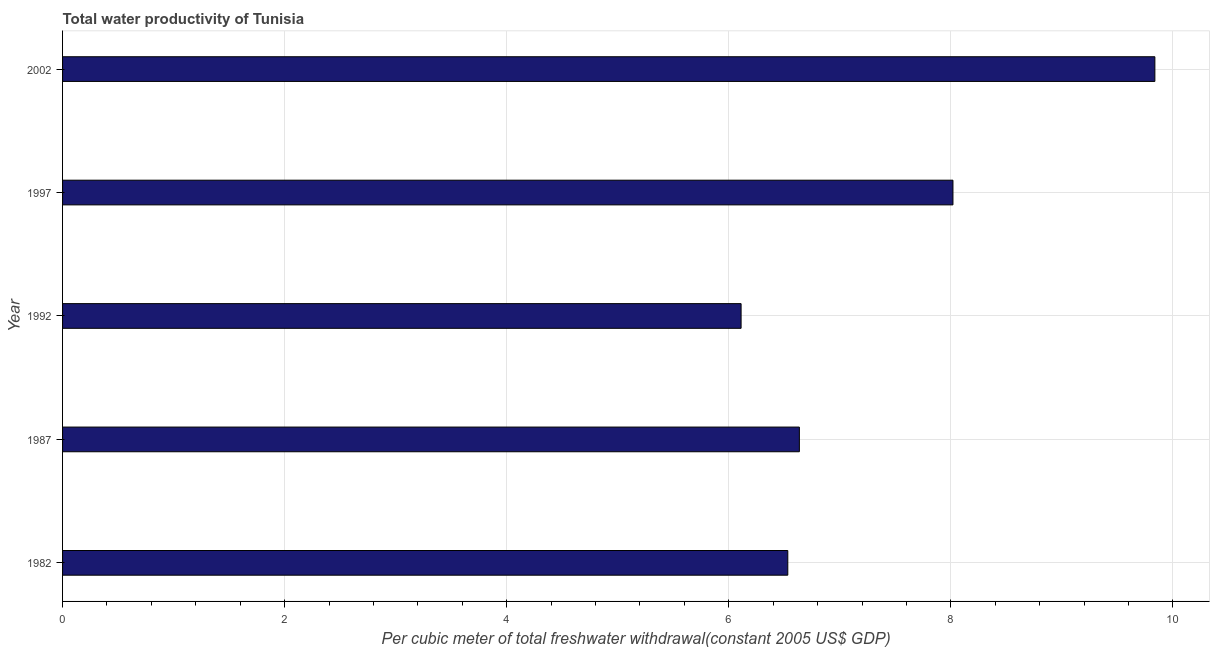Does the graph contain any zero values?
Provide a short and direct response. No. Does the graph contain grids?
Provide a short and direct response. Yes. What is the title of the graph?
Provide a short and direct response. Total water productivity of Tunisia. What is the label or title of the X-axis?
Offer a very short reply. Per cubic meter of total freshwater withdrawal(constant 2005 US$ GDP). What is the label or title of the Y-axis?
Ensure brevity in your answer.  Year. What is the total water productivity in 1997?
Your answer should be very brief. 8.02. Across all years, what is the maximum total water productivity?
Provide a short and direct response. 9.84. Across all years, what is the minimum total water productivity?
Give a very brief answer. 6.11. In which year was the total water productivity maximum?
Offer a very short reply. 2002. In which year was the total water productivity minimum?
Offer a terse response. 1992. What is the sum of the total water productivity?
Your answer should be very brief. 37.13. What is the difference between the total water productivity in 1997 and 2002?
Keep it short and to the point. -1.82. What is the average total water productivity per year?
Offer a terse response. 7.43. What is the median total water productivity?
Make the answer very short. 6.64. Do a majority of the years between 2002 and 1997 (inclusive) have total water productivity greater than 3.2 US$?
Give a very brief answer. No. What is the ratio of the total water productivity in 1987 to that in 1992?
Ensure brevity in your answer.  1.09. Is the difference between the total water productivity in 1992 and 2002 greater than the difference between any two years?
Give a very brief answer. Yes. What is the difference between the highest and the second highest total water productivity?
Offer a very short reply. 1.82. What is the difference between the highest and the lowest total water productivity?
Offer a terse response. 3.73. In how many years, is the total water productivity greater than the average total water productivity taken over all years?
Provide a short and direct response. 2. Are all the bars in the graph horizontal?
Offer a terse response. Yes. What is the difference between two consecutive major ticks on the X-axis?
Your answer should be very brief. 2. What is the Per cubic meter of total freshwater withdrawal(constant 2005 US$ GDP) of 1982?
Keep it short and to the point. 6.53. What is the Per cubic meter of total freshwater withdrawal(constant 2005 US$ GDP) in 1987?
Your response must be concise. 6.64. What is the Per cubic meter of total freshwater withdrawal(constant 2005 US$ GDP) of 1992?
Give a very brief answer. 6.11. What is the Per cubic meter of total freshwater withdrawal(constant 2005 US$ GDP) of 1997?
Offer a very short reply. 8.02. What is the Per cubic meter of total freshwater withdrawal(constant 2005 US$ GDP) of 2002?
Give a very brief answer. 9.84. What is the difference between the Per cubic meter of total freshwater withdrawal(constant 2005 US$ GDP) in 1982 and 1987?
Provide a succinct answer. -0.1. What is the difference between the Per cubic meter of total freshwater withdrawal(constant 2005 US$ GDP) in 1982 and 1992?
Keep it short and to the point. 0.42. What is the difference between the Per cubic meter of total freshwater withdrawal(constant 2005 US$ GDP) in 1982 and 1997?
Offer a very short reply. -1.49. What is the difference between the Per cubic meter of total freshwater withdrawal(constant 2005 US$ GDP) in 1982 and 2002?
Give a very brief answer. -3.31. What is the difference between the Per cubic meter of total freshwater withdrawal(constant 2005 US$ GDP) in 1987 and 1992?
Ensure brevity in your answer.  0.52. What is the difference between the Per cubic meter of total freshwater withdrawal(constant 2005 US$ GDP) in 1987 and 1997?
Provide a succinct answer. -1.38. What is the difference between the Per cubic meter of total freshwater withdrawal(constant 2005 US$ GDP) in 1987 and 2002?
Your answer should be very brief. -3.2. What is the difference between the Per cubic meter of total freshwater withdrawal(constant 2005 US$ GDP) in 1992 and 1997?
Provide a succinct answer. -1.91. What is the difference between the Per cubic meter of total freshwater withdrawal(constant 2005 US$ GDP) in 1992 and 2002?
Give a very brief answer. -3.73. What is the difference between the Per cubic meter of total freshwater withdrawal(constant 2005 US$ GDP) in 1997 and 2002?
Your answer should be very brief. -1.82. What is the ratio of the Per cubic meter of total freshwater withdrawal(constant 2005 US$ GDP) in 1982 to that in 1987?
Keep it short and to the point. 0.98. What is the ratio of the Per cubic meter of total freshwater withdrawal(constant 2005 US$ GDP) in 1982 to that in 1992?
Ensure brevity in your answer.  1.07. What is the ratio of the Per cubic meter of total freshwater withdrawal(constant 2005 US$ GDP) in 1982 to that in 1997?
Provide a succinct answer. 0.81. What is the ratio of the Per cubic meter of total freshwater withdrawal(constant 2005 US$ GDP) in 1982 to that in 2002?
Provide a succinct answer. 0.66. What is the ratio of the Per cubic meter of total freshwater withdrawal(constant 2005 US$ GDP) in 1987 to that in 1992?
Make the answer very short. 1.09. What is the ratio of the Per cubic meter of total freshwater withdrawal(constant 2005 US$ GDP) in 1987 to that in 1997?
Your response must be concise. 0.83. What is the ratio of the Per cubic meter of total freshwater withdrawal(constant 2005 US$ GDP) in 1987 to that in 2002?
Your answer should be very brief. 0.68. What is the ratio of the Per cubic meter of total freshwater withdrawal(constant 2005 US$ GDP) in 1992 to that in 1997?
Provide a succinct answer. 0.76. What is the ratio of the Per cubic meter of total freshwater withdrawal(constant 2005 US$ GDP) in 1992 to that in 2002?
Keep it short and to the point. 0.62. What is the ratio of the Per cubic meter of total freshwater withdrawal(constant 2005 US$ GDP) in 1997 to that in 2002?
Your answer should be compact. 0.81. 